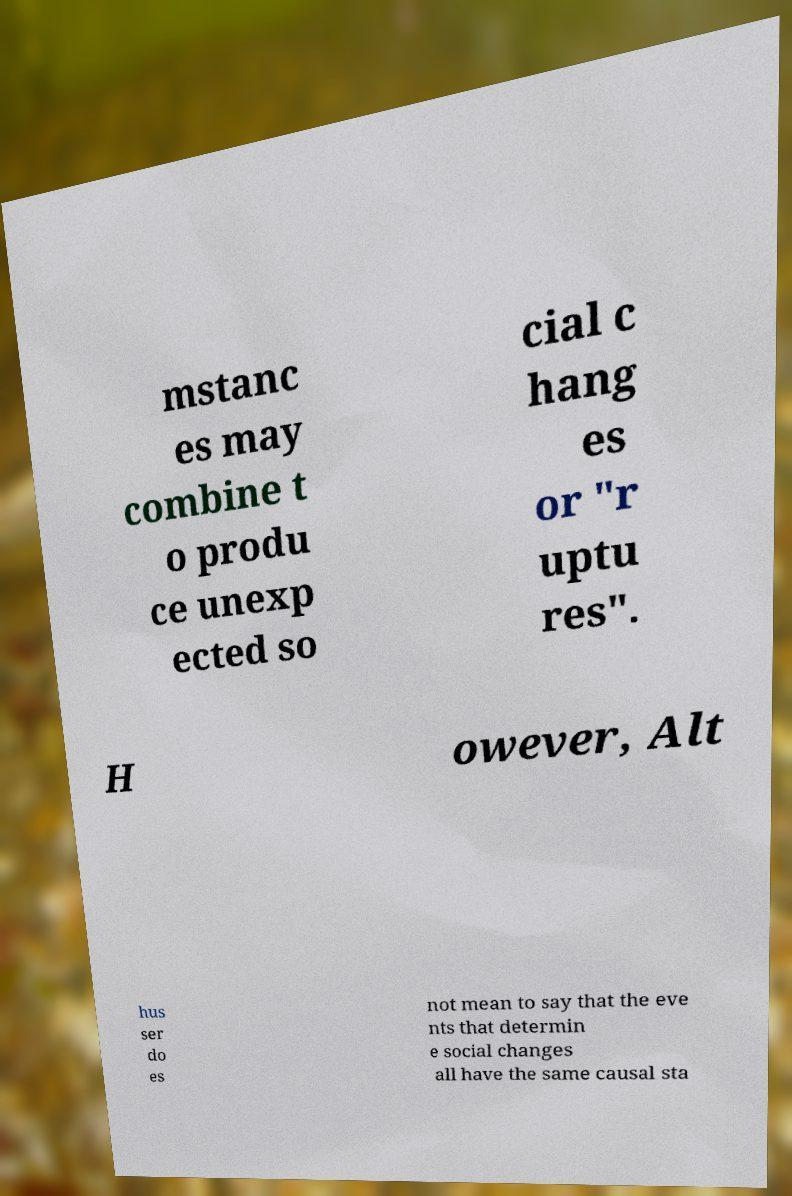Please identify and transcribe the text found in this image. mstanc es may combine t o produ ce unexp ected so cial c hang es or "r uptu res". H owever, Alt hus ser do es not mean to say that the eve nts that determin e social changes all have the same causal sta 